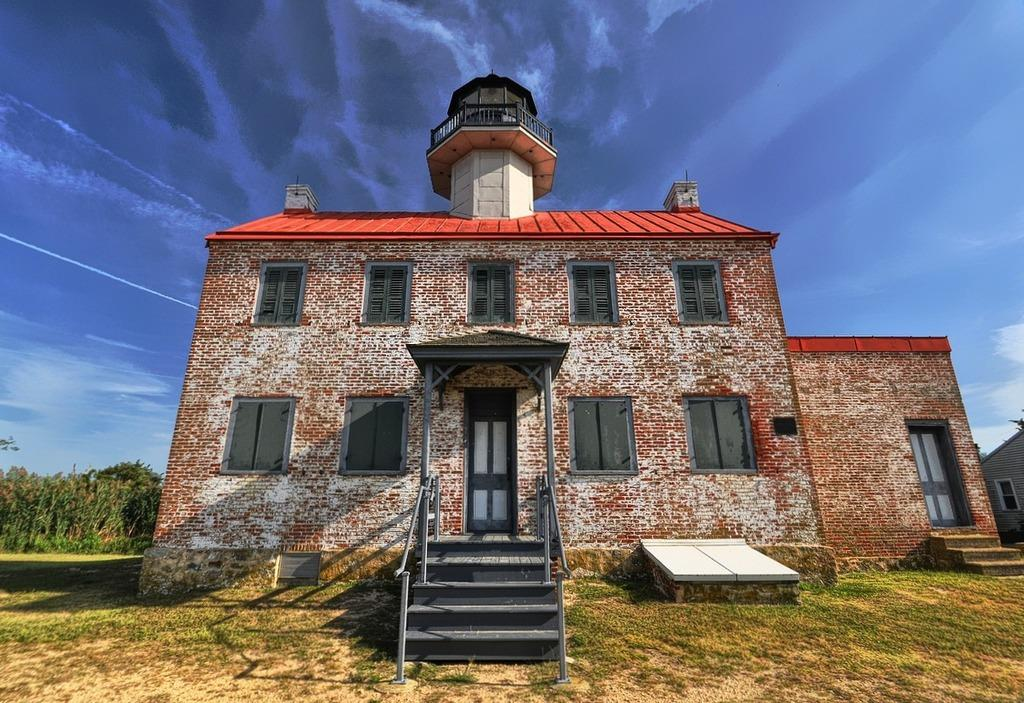What type of structure is in the image? There is a building in the image. What architectural feature is located in front of the building? There are stairs in front of the building. What is visible beneath the building and stairs? There is ground visible in the image. What type of vegetation is on the left side of the image? There are trees on the left side of the image. What is visible at the top of the image? The sky is visible at the top of the image. What type of wire is used to create the sense of depth in the image? There is no wire present in the image, and the sense of depth is created by the perspective and arrangement of the building, stairs, trees, and sky. 